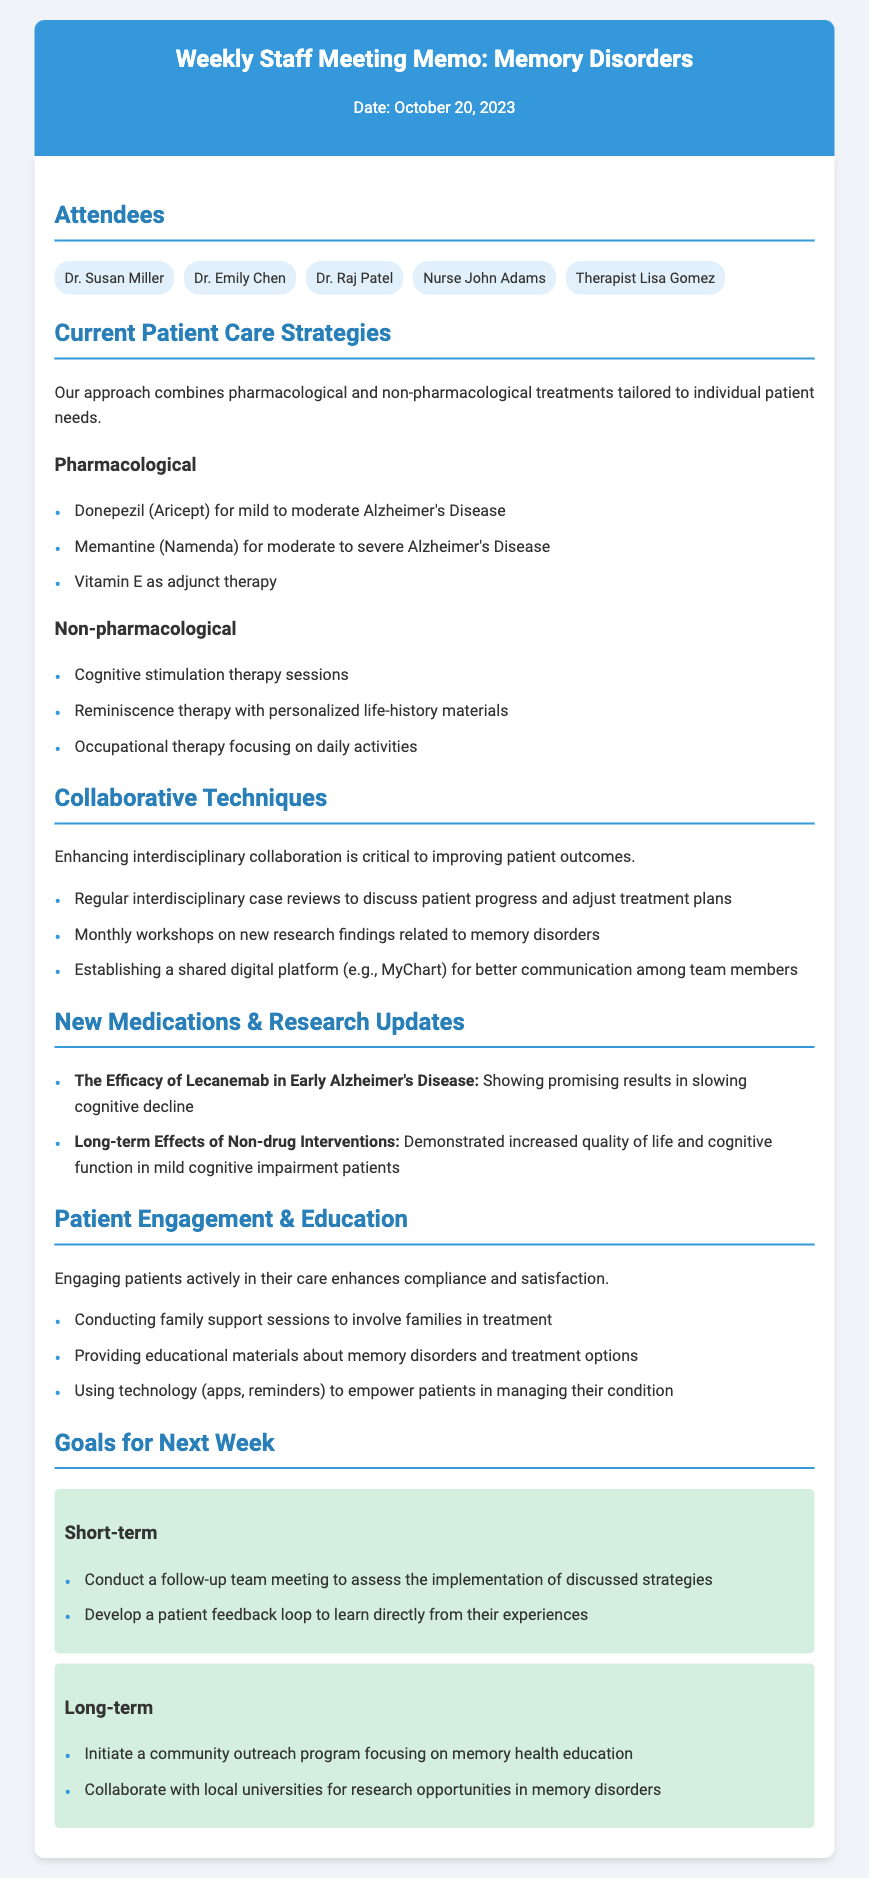What is the date of the meeting? The date of the meeting is explicitly stated in the document header.
Answer: October 20, 2023 Who is one of the attendees? The attendees are listed in the document under the "Attendees" section.
Answer: Dr. Susan Miller What is one pharmacological treatment mentioned for Alzheimer's disease? The document lists specific pharmacological treatments under "Pharmacological" strategies.
Answer: Donepezil (Aricept) What are cognitive stimulation therapy sessions classified as? The document categorizes different non-pharmacological treatments, including this therapy.
Answer: Non-pharmacological What is one of the long-term goals for next week? The goals are separated into short-term and long-term, listed under the respective sections.
Answer: Initiate a community outreach program focusing on memory health education What is the purpose of establishing a shared digital platform? The document explains the significance of improving communication among team members in the "Collaborative Techniques" section.
Answer: Better communication among team members How many strategies are listed under Current Patient Care Strategies? The document contains two sections for strategies, each containing a list.
Answer: Two What is the main focus of the "Patient Engagement & Education" section? This section highlights the importance of involving patients in their care for better outcomes.
Answer: Engaging patients actively in their care What type of updates are provided under "New Medications & Research Updates"? This section includes updates on the efficacy of certain treatments and research findings.
Answer: Research updates 